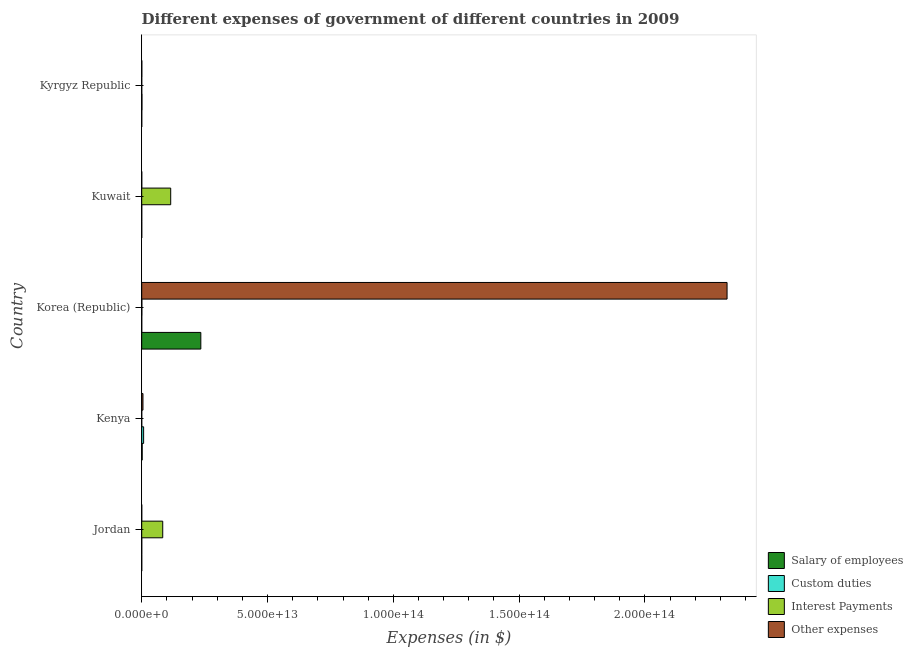Are the number of bars per tick equal to the number of legend labels?
Provide a short and direct response. Yes. Are the number of bars on each tick of the Y-axis equal?
Your response must be concise. Yes. How many bars are there on the 4th tick from the bottom?
Give a very brief answer. 4. What is the label of the 1st group of bars from the top?
Keep it short and to the point. Kyrgyz Republic. What is the amount spent on custom duties in Kuwait?
Your response must be concise. 1.85e+09. Across all countries, what is the maximum amount spent on interest payments?
Ensure brevity in your answer.  1.15e+13. Across all countries, what is the minimum amount spent on salary of employees?
Provide a succinct answer. 2.53e+09. In which country was the amount spent on custom duties maximum?
Offer a terse response. Kenya. In which country was the amount spent on custom duties minimum?
Offer a very short reply. Kuwait. What is the total amount spent on interest payments in the graph?
Offer a very short reply. 1.99e+13. What is the difference between the amount spent on custom duties in Jordan and that in Kyrgyz Republic?
Make the answer very short. -8.48e+1. What is the difference between the amount spent on salary of employees in Kuwait and the amount spent on interest payments in Jordan?
Give a very brief answer. -8.35e+12. What is the average amount spent on salary of employees per country?
Offer a terse response. 4.74e+12. What is the difference between the amount spent on interest payments and amount spent on other expenses in Kenya?
Make the answer very short. -4.93e+11. In how many countries, is the amount spent on interest payments greater than 200000000000000 $?
Make the answer very short. 0. What is the ratio of the amount spent on custom duties in Korea (Republic) to that in Kyrgyz Republic?
Offer a very short reply. 0.02. Is the amount spent on salary of employees in Kenya less than that in Kyrgyz Republic?
Provide a succinct answer. No. Is the difference between the amount spent on custom duties in Jordan and Kyrgyz Republic greater than the difference between the amount spent on salary of employees in Jordan and Kyrgyz Republic?
Offer a terse response. No. What is the difference between the highest and the second highest amount spent on other expenses?
Offer a very short reply. 2.32e+14. What is the difference between the highest and the lowest amount spent on other expenses?
Your answer should be compact. 2.33e+14. What does the 2nd bar from the top in Kyrgyz Republic represents?
Offer a very short reply. Interest Payments. What does the 1st bar from the bottom in Jordan represents?
Offer a terse response. Salary of employees. Is it the case that in every country, the sum of the amount spent on salary of employees and amount spent on custom duties is greater than the amount spent on interest payments?
Your answer should be compact. No. How many bars are there?
Offer a terse response. 20. How many countries are there in the graph?
Your answer should be very brief. 5. What is the difference between two consecutive major ticks on the X-axis?
Offer a very short reply. 5.00e+13. Are the values on the major ticks of X-axis written in scientific E-notation?
Make the answer very short. Yes. Does the graph contain any zero values?
Offer a very short reply. No. Where does the legend appear in the graph?
Offer a terse response. Bottom right. How many legend labels are there?
Offer a terse response. 4. How are the legend labels stacked?
Make the answer very short. Vertical. What is the title of the graph?
Offer a terse response. Different expenses of government of different countries in 2009. What is the label or title of the X-axis?
Your answer should be very brief. Expenses (in $). What is the Expenses (in $) of Salary of employees in Jordan?
Keep it short and to the point. 2.53e+09. What is the Expenses (in $) in Custom duties in Jordan?
Your answer should be very brief. 5.23e+09. What is the Expenses (in $) of Interest Payments in Jordan?
Provide a succinct answer. 8.35e+12. What is the Expenses (in $) in Other expenses in Jordan?
Offer a very short reply. 5.09e+09. What is the Expenses (in $) of Salary of employees in Kenya?
Provide a succinct answer. 1.84e+11. What is the Expenses (in $) in Custom duties in Kenya?
Your answer should be very brief. 7.53e+11. What is the Expenses (in $) of Interest Payments in Kenya?
Make the answer very short. 3.92e+08. What is the Expenses (in $) in Other expenses in Kenya?
Your answer should be very brief. 4.94e+11. What is the Expenses (in $) of Salary of employees in Korea (Republic)?
Your answer should be compact. 2.35e+13. What is the Expenses (in $) in Custom duties in Korea (Republic)?
Your answer should be compact. 2.11e+09. What is the Expenses (in $) of Interest Payments in Korea (Republic)?
Provide a succinct answer. 5.06e+1. What is the Expenses (in $) of Other expenses in Korea (Republic)?
Offer a terse response. 2.33e+14. What is the Expenses (in $) in Salary of employees in Kuwait?
Your answer should be compact. 2.98e+09. What is the Expenses (in $) in Custom duties in Kuwait?
Offer a terse response. 1.85e+09. What is the Expenses (in $) in Interest Payments in Kuwait?
Make the answer very short. 1.15e+13. What is the Expenses (in $) in Other expenses in Kuwait?
Provide a short and direct response. 1.03e+1. What is the Expenses (in $) of Salary of employees in Kyrgyz Republic?
Ensure brevity in your answer.  1.09e+1. What is the Expenses (in $) of Custom duties in Kyrgyz Republic?
Offer a very short reply. 9.01e+1. What is the Expenses (in $) of Interest Payments in Kyrgyz Republic?
Offer a terse response. 1.59e+09. What is the Expenses (in $) in Other expenses in Kyrgyz Republic?
Provide a short and direct response. 3.79e+1. Across all countries, what is the maximum Expenses (in $) in Salary of employees?
Your response must be concise. 2.35e+13. Across all countries, what is the maximum Expenses (in $) of Custom duties?
Give a very brief answer. 7.53e+11. Across all countries, what is the maximum Expenses (in $) of Interest Payments?
Make the answer very short. 1.15e+13. Across all countries, what is the maximum Expenses (in $) of Other expenses?
Offer a very short reply. 2.33e+14. Across all countries, what is the minimum Expenses (in $) of Salary of employees?
Make the answer very short. 2.53e+09. Across all countries, what is the minimum Expenses (in $) of Custom duties?
Make the answer very short. 1.85e+09. Across all countries, what is the minimum Expenses (in $) of Interest Payments?
Provide a short and direct response. 3.92e+08. Across all countries, what is the minimum Expenses (in $) of Other expenses?
Provide a succinct answer. 5.09e+09. What is the total Expenses (in $) in Salary of employees in the graph?
Keep it short and to the point. 2.37e+13. What is the total Expenses (in $) in Custom duties in the graph?
Ensure brevity in your answer.  8.53e+11. What is the total Expenses (in $) in Interest Payments in the graph?
Your response must be concise. 1.99e+13. What is the total Expenses (in $) in Other expenses in the graph?
Offer a terse response. 2.33e+14. What is the difference between the Expenses (in $) of Salary of employees in Jordan and that in Kenya?
Make the answer very short. -1.82e+11. What is the difference between the Expenses (in $) of Custom duties in Jordan and that in Kenya?
Make the answer very short. -7.48e+11. What is the difference between the Expenses (in $) of Interest Payments in Jordan and that in Kenya?
Keep it short and to the point. 8.35e+12. What is the difference between the Expenses (in $) in Other expenses in Jordan and that in Kenya?
Give a very brief answer. -4.89e+11. What is the difference between the Expenses (in $) of Salary of employees in Jordan and that in Korea (Republic)?
Provide a short and direct response. -2.35e+13. What is the difference between the Expenses (in $) in Custom duties in Jordan and that in Korea (Republic)?
Give a very brief answer. 3.11e+09. What is the difference between the Expenses (in $) in Interest Payments in Jordan and that in Korea (Republic)?
Ensure brevity in your answer.  8.30e+12. What is the difference between the Expenses (in $) of Other expenses in Jordan and that in Korea (Republic)?
Provide a succinct answer. -2.33e+14. What is the difference between the Expenses (in $) in Salary of employees in Jordan and that in Kuwait?
Provide a succinct answer. -4.51e+08. What is the difference between the Expenses (in $) in Custom duties in Jordan and that in Kuwait?
Ensure brevity in your answer.  3.38e+09. What is the difference between the Expenses (in $) of Interest Payments in Jordan and that in Kuwait?
Offer a very short reply. -3.17e+12. What is the difference between the Expenses (in $) of Other expenses in Jordan and that in Kuwait?
Your answer should be compact. -5.18e+09. What is the difference between the Expenses (in $) of Salary of employees in Jordan and that in Kyrgyz Republic?
Give a very brief answer. -8.40e+09. What is the difference between the Expenses (in $) of Custom duties in Jordan and that in Kyrgyz Republic?
Offer a very short reply. -8.48e+1. What is the difference between the Expenses (in $) in Interest Payments in Jordan and that in Kyrgyz Republic?
Provide a short and direct response. 8.35e+12. What is the difference between the Expenses (in $) in Other expenses in Jordan and that in Kyrgyz Republic?
Offer a terse response. -3.28e+1. What is the difference between the Expenses (in $) of Salary of employees in Kenya and that in Korea (Republic)?
Provide a succinct answer. -2.33e+13. What is the difference between the Expenses (in $) of Custom duties in Kenya and that in Korea (Republic)?
Ensure brevity in your answer.  7.51e+11. What is the difference between the Expenses (in $) in Interest Payments in Kenya and that in Korea (Republic)?
Keep it short and to the point. -5.02e+1. What is the difference between the Expenses (in $) in Other expenses in Kenya and that in Korea (Republic)?
Provide a short and direct response. -2.32e+14. What is the difference between the Expenses (in $) of Salary of employees in Kenya and that in Kuwait?
Offer a very short reply. 1.81e+11. What is the difference between the Expenses (in $) of Custom duties in Kenya and that in Kuwait?
Your response must be concise. 7.52e+11. What is the difference between the Expenses (in $) of Interest Payments in Kenya and that in Kuwait?
Your answer should be very brief. -1.15e+13. What is the difference between the Expenses (in $) in Other expenses in Kenya and that in Kuwait?
Offer a terse response. 4.84e+11. What is the difference between the Expenses (in $) in Salary of employees in Kenya and that in Kyrgyz Republic?
Make the answer very short. 1.73e+11. What is the difference between the Expenses (in $) in Custom duties in Kenya and that in Kyrgyz Republic?
Make the answer very short. 6.63e+11. What is the difference between the Expenses (in $) in Interest Payments in Kenya and that in Kyrgyz Republic?
Keep it short and to the point. -1.20e+09. What is the difference between the Expenses (in $) of Other expenses in Kenya and that in Kyrgyz Republic?
Provide a short and direct response. 4.56e+11. What is the difference between the Expenses (in $) in Salary of employees in Korea (Republic) and that in Kuwait?
Your response must be concise. 2.35e+13. What is the difference between the Expenses (in $) of Custom duties in Korea (Republic) and that in Kuwait?
Make the answer very short. 2.65e+08. What is the difference between the Expenses (in $) in Interest Payments in Korea (Republic) and that in Kuwait?
Give a very brief answer. -1.15e+13. What is the difference between the Expenses (in $) of Other expenses in Korea (Republic) and that in Kuwait?
Ensure brevity in your answer.  2.33e+14. What is the difference between the Expenses (in $) in Salary of employees in Korea (Republic) and that in Kyrgyz Republic?
Provide a succinct answer. 2.35e+13. What is the difference between the Expenses (in $) of Custom duties in Korea (Republic) and that in Kyrgyz Republic?
Your answer should be compact. -8.79e+1. What is the difference between the Expenses (in $) in Interest Payments in Korea (Republic) and that in Kyrgyz Republic?
Your response must be concise. 4.90e+1. What is the difference between the Expenses (in $) in Other expenses in Korea (Republic) and that in Kyrgyz Republic?
Offer a very short reply. 2.33e+14. What is the difference between the Expenses (in $) in Salary of employees in Kuwait and that in Kyrgyz Republic?
Offer a very short reply. -7.95e+09. What is the difference between the Expenses (in $) of Custom duties in Kuwait and that in Kyrgyz Republic?
Your answer should be compact. -8.82e+1. What is the difference between the Expenses (in $) of Interest Payments in Kuwait and that in Kyrgyz Republic?
Offer a very short reply. 1.15e+13. What is the difference between the Expenses (in $) in Other expenses in Kuwait and that in Kyrgyz Republic?
Provide a short and direct response. -2.76e+1. What is the difference between the Expenses (in $) of Salary of employees in Jordan and the Expenses (in $) of Custom duties in Kenya?
Give a very brief answer. -7.51e+11. What is the difference between the Expenses (in $) in Salary of employees in Jordan and the Expenses (in $) in Interest Payments in Kenya?
Keep it short and to the point. 2.14e+09. What is the difference between the Expenses (in $) of Salary of employees in Jordan and the Expenses (in $) of Other expenses in Kenya?
Give a very brief answer. -4.91e+11. What is the difference between the Expenses (in $) of Custom duties in Jordan and the Expenses (in $) of Interest Payments in Kenya?
Make the answer very short. 4.84e+09. What is the difference between the Expenses (in $) of Custom duties in Jordan and the Expenses (in $) of Other expenses in Kenya?
Provide a short and direct response. -4.89e+11. What is the difference between the Expenses (in $) in Interest Payments in Jordan and the Expenses (in $) in Other expenses in Kenya?
Ensure brevity in your answer.  7.86e+12. What is the difference between the Expenses (in $) of Salary of employees in Jordan and the Expenses (in $) of Custom duties in Korea (Republic)?
Your answer should be very brief. 4.19e+08. What is the difference between the Expenses (in $) of Salary of employees in Jordan and the Expenses (in $) of Interest Payments in Korea (Republic)?
Give a very brief answer. -4.81e+1. What is the difference between the Expenses (in $) in Salary of employees in Jordan and the Expenses (in $) in Other expenses in Korea (Republic)?
Your answer should be very brief. -2.33e+14. What is the difference between the Expenses (in $) of Custom duties in Jordan and the Expenses (in $) of Interest Payments in Korea (Republic)?
Your answer should be very brief. -4.54e+1. What is the difference between the Expenses (in $) in Custom duties in Jordan and the Expenses (in $) in Other expenses in Korea (Republic)?
Make the answer very short. -2.33e+14. What is the difference between the Expenses (in $) of Interest Payments in Jordan and the Expenses (in $) of Other expenses in Korea (Republic)?
Your answer should be compact. -2.24e+14. What is the difference between the Expenses (in $) of Salary of employees in Jordan and the Expenses (in $) of Custom duties in Kuwait?
Your response must be concise. 6.84e+08. What is the difference between the Expenses (in $) in Salary of employees in Jordan and the Expenses (in $) in Interest Payments in Kuwait?
Your answer should be very brief. -1.15e+13. What is the difference between the Expenses (in $) in Salary of employees in Jordan and the Expenses (in $) in Other expenses in Kuwait?
Keep it short and to the point. -7.74e+09. What is the difference between the Expenses (in $) of Custom duties in Jordan and the Expenses (in $) of Interest Payments in Kuwait?
Provide a succinct answer. -1.15e+13. What is the difference between the Expenses (in $) in Custom duties in Jordan and the Expenses (in $) in Other expenses in Kuwait?
Provide a succinct answer. -5.04e+09. What is the difference between the Expenses (in $) in Interest Payments in Jordan and the Expenses (in $) in Other expenses in Kuwait?
Offer a terse response. 8.34e+12. What is the difference between the Expenses (in $) of Salary of employees in Jordan and the Expenses (in $) of Custom duties in Kyrgyz Republic?
Offer a very short reply. -8.75e+1. What is the difference between the Expenses (in $) of Salary of employees in Jordan and the Expenses (in $) of Interest Payments in Kyrgyz Republic?
Make the answer very short. 9.41e+08. What is the difference between the Expenses (in $) of Salary of employees in Jordan and the Expenses (in $) of Other expenses in Kyrgyz Republic?
Provide a short and direct response. -3.53e+1. What is the difference between the Expenses (in $) of Custom duties in Jordan and the Expenses (in $) of Interest Payments in Kyrgyz Republic?
Your answer should be compact. 3.64e+09. What is the difference between the Expenses (in $) of Custom duties in Jordan and the Expenses (in $) of Other expenses in Kyrgyz Republic?
Give a very brief answer. -3.26e+1. What is the difference between the Expenses (in $) of Interest Payments in Jordan and the Expenses (in $) of Other expenses in Kyrgyz Republic?
Your answer should be very brief. 8.31e+12. What is the difference between the Expenses (in $) of Salary of employees in Kenya and the Expenses (in $) of Custom duties in Korea (Republic)?
Your response must be concise. 1.82e+11. What is the difference between the Expenses (in $) of Salary of employees in Kenya and the Expenses (in $) of Interest Payments in Korea (Republic)?
Give a very brief answer. 1.34e+11. What is the difference between the Expenses (in $) in Salary of employees in Kenya and the Expenses (in $) in Other expenses in Korea (Republic)?
Offer a very short reply. -2.32e+14. What is the difference between the Expenses (in $) of Custom duties in Kenya and the Expenses (in $) of Interest Payments in Korea (Republic)?
Your answer should be very brief. 7.03e+11. What is the difference between the Expenses (in $) in Custom duties in Kenya and the Expenses (in $) in Other expenses in Korea (Republic)?
Keep it short and to the point. -2.32e+14. What is the difference between the Expenses (in $) in Interest Payments in Kenya and the Expenses (in $) in Other expenses in Korea (Republic)?
Your response must be concise. -2.33e+14. What is the difference between the Expenses (in $) in Salary of employees in Kenya and the Expenses (in $) in Custom duties in Kuwait?
Your answer should be very brief. 1.82e+11. What is the difference between the Expenses (in $) of Salary of employees in Kenya and the Expenses (in $) of Interest Payments in Kuwait?
Give a very brief answer. -1.13e+13. What is the difference between the Expenses (in $) in Salary of employees in Kenya and the Expenses (in $) in Other expenses in Kuwait?
Your response must be concise. 1.74e+11. What is the difference between the Expenses (in $) in Custom duties in Kenya and the Expenses (in $) in Interest Payments in Kuwait?
Ensure brevity in your answer.  -1.08e+13. What is the difference between the Expenses (in $) in Custom duties in Kenya and the Expenses (in $) in Other expenses in Kuwait?
Give a very brief answer. 7.43e+11. What is the difference between the Expenses (in $) in Interest Payments in Kenya and the Expenses (in $) in Other expenses in Kuwait?
Your answer should be very brief. -9.88e+09. What is the difference between the Expenses (in $) in Salary of employees in Kenya and the Expenses (in $) in Custom duties in Kyrgyz Republic?
Your answer should be very brief. 9.42e+1. What is the difference between the Expenses (in $) in Salary of employees in Kenya and the Expenses (in $) in Interest Payments in Kyrgyz Republic?
Your answer should be compact. 1.83e+11. What is the difference between the Expenses (in $) in Salary of employees in Kenya and the Expenses (in $) in Other expenses in Kyrgyz Republic?
Make the answer very short. 1.46e+11. What is the difference between the Expenses (in $) in Custom duties in Kenya and the Expenses (in $) in Interest Payments in Kyrgyz Republic?
Your answer should be very brief. 7.52e+11. What is the difference between the Expenses (in $) in Custom duties in Kenya and the Expenses (in $) in Other expenses in Kyrgyz Republic?
Offer a very short reply. 7.16e+11. What is the difference between the Expenses (in $) of Interest Payments in Kenya and the Expenses (in $) of Other expenses in Kyrgyz Republic?
Offer a terse response. -3.75e+1. What is the difference between the Expenses (in $) in Salary of employees in Korea (Republic) and the Expenses (in $) in Custom duties in Kuwait?
Keep it short and to the point. 2.35e+13. What is the difference between the Expenses (in $) of Salary of employees in Korea (Republic) and the Expenses (in $) of Interest Payments in Kuwait?
Offer a very short reply. 1.20e+13. What is the difference between the Expenses (in $) in Salary of employees in Korea (Republic) and the Expenses (in $) in Other expenses in Kuwait?
Offer a terse response. 2.35e+13. What is the difference between the Expenses (in $) in Custom duties in Korea (Republic) and the Expenses (in $) in Interest Payments in Kuwait?
Provide a succinct answer. -1.15e+13. What is the difference between the Expenses (in $) in Custom duties in Korea (Republic) and the Expenses (in $) in Other expenses in Kuwait?
Keep it short and to the point. -8.15e+09. What is the difference between the Expenses (in $) of Interest Payments in Korea (Republic) and the Expenses (in $) of Other expenses in Kuwait?
Your answer should be very brief. 4.04e+1. What is the difference between the Expenses (in $) of Salary of employees in Korea (Republic) and the Expenses (in $) of Custom duties in Kyrgyz Republic?
Make the answer very short. 2.34e+13. What is the difference between the Expenses (in $) in Salary of employees in Korea (Republic) and the Expenses (in $) in Interest Payments in Kyrgyz Republic?
Give a very brief answer. 2.35e+13. What is the difference between the Expenses (in $) in Salary of employees in Korea (Republic) and the Expenses (in $) in Other expenses in Kyrgyz Republic?
Your response must be concise. 2.35e+13. What is the difference between the Expenses (in $) of Custom duties in Korea (Republic) and the Expenses (in $) of Interest Payments in Kyrgyz Republic?
Offer a terse response. 5.22e+08. What is the difference between the Expenses (in $) of Custom duties in Korea (Republic) and the Expenses (in $) of Other expenses in Kyrgyz Republic?
Make the answer very short. -3.57e+1. What is the difference between the Expenses (in $) in Interest Payments in Korea (Republic) and the Expenses (in $) in Other expenses in Kyrgyz Republic?
Make the answer very short. 1.28e+1. What is the difference between the Expenses (in $) of Salary of employees in Kuwait and the Expenses (in $) of Custom duties in Kyrgyz Republic?
Give a very brief answer. -8.71e+1. What is the difference between the Expenses (in $) in Salary of employees in Kuwait and the Expenses (in $) in Interest Payments in Kyrgyz Republic?
Your response must be concise. 1.39e+09. What is the difference between the Expenses (in $) in Salary of employees in Kuwait and the Expenses (in $) in Other expenses in Kyrgyz Republic?
Give a very brief answer. -3.49e+1. What is the difference between the Expenses (in $) in Custom duties in Kuwait and the Expenses (in $) in Interest Payments in Kyrgyz Republic?
Keep it short and to the point. 2.56e+08. What is the difference between the Expenses (in $) of Custom duties in Kuwait and the Expenses (in $) of Other expenses in Kyrgyz Republic?
Ensure brevity in your answer.  -3.60e+1. What is the difference between the Expenses (in $) of Interest Payments in Kuwait and the Expenses (in $) of Other expenses in Kyrgyz Republic?
Make the answer very short. 1.15e+13. What is the average Expenses (in $) of Salary of employees per country?
Offer a terse response. 4.74e+12. What is the average Expenses (in $) of Custom duties per country?
Keep it short and to the point. 1.71e+11. What is the average Expenses (in $) in Interest Payments per country?
Provide a short and direct response. 3.98e+12. What is the average Expenses (in $) of Other expenses per country?
Provide a succinct answer. 4.66e+13. What is the difference between the Expenses (in $) in Salary of employees and Expenses (in $) in Custom duties in Jordan?
Provide a short and direct response. -2.70e+09. What is the difference between the Expenses (in $) of Salary of employees and Expenses (in $) of Interest Payments in Jordan?
Offer a very short reply. -8.35e+12. What is the difference between the Expenses (in $) in Salary of employees and Expenses (in $) in Other expenses in Jordan?
Ensure brevity in your answer.  -2.56e+09. What is the difference between the Expenses (in $) in Custom duties and Expenses (in $) in Interest Payments in Jordan?
Your answer should be very brief. -8.35e+12. What is the difference between the Expenses (in $) in Custom duties and Expenses (in $) in Other expenses in Jordan?
Offer a terse response. 1.39e+08. What is the difference between the Expenses (in $) in Interest Payments and Expenses (in $) in Other expenses in Jordan?
Provide a short and direct response. 8.35e+12. What is the difference between the Expenses (in $) in Salary of employees and Expenses (in $) in Custom duties in Kenya?
Provide a succinct answer. -5.69e+11. What is the difference between the Expenses (in $) of Salary of employees and Expenses (in $) of Interest Payments in Kenya?
Provide a short and direct response. 1.84e+11. What is the difference between the Expenses (in $) of Salary of employees and Expenses (in $) of Other expenses in Kenya?
Offer a very short reply. -3.10e+11. What is the difference between the Expenses (in $) of Custom duties and Expenses (in $) of Interest Payments in Kenya?
Make the answer very short. 7.53e+11. What is the difference between the Expenses (in $) of Custom duties and Expenses (in $) of Other expenses in Kenya?
Your answer should be very brief. 2.60e+11. What is the difference between the Expenses (in $) of Interest Payments and Expenses (in $) of Other expenses in Kenya?
Your response must be concise. -4.93e+11. What is the difference between the Expenses (in $) of Salary of employees and Expenses (in $) of Custom duties in Korea (Republic)?
Your answer should be very brief. 2.35e+13. What is the difference between the Expenses (in $) in Salary of employees and Expenses (in $) in Interest Payments in Korea (Republic)?
Provide a succinct answer. 2.34e+13. What is the difference between the Expenses (in $) of Salary of employees and Expenses (in $) of Other expenses in Korea (Republic)?
Make the answer very short. -2.09e+14. What is the difference between the Expenses (in $) of Custom duties and Expenses (in $) of Interest Payments in Korea (Republic)?
Provide a succinct answer. -4.85e+1. What is the difference between the Expenses (in $) in Custom duties and Expenses (in $) in Other expenses in Korea (Republic)?
Give a very brief answer. -2.33e+14. What is the difference between the Expenses (in $) in Interest Payments and Expenses (in $) in Other expenses in Korea (Republic)?
Offer a terse response. -2.33e+14. What is the difference between the Expenses (in $) of Salary of employees and Expenses (in $) of Custom duties in Kuwait?
Make the answer very short. 1.14e+09. What is the difference between the Expenses (in $) of Salary of employees and Expenses (in $) of Interest Payments in Kuwait?
Make the answer very short. -1.15e+13. What is the difference between the Expenses (in $) in Salary of employees and Expenses (in $) in Other expenses in Kuwait?
Your response must be concise. -7.28e+09. What is the difference between the Expenses (in $) in Custom duties and Expenses (in $) in Interest Payments in Kuwait?
Give a very brief answer. -1.15e+13. What is the difference between the Expenses (in $) in Custom duties and Expenses (in $) in Other expenses in Kuwait?
Offer a terse response. -8.42e+09. What is the difference between the Expenses (in $) of Interest Payments and Expenses (in $) of Other expenses in Kuwait?
Your answer should be very brief. 1.15e+13. What is the difference between the Expenses (in $) of Salary of employees and Expenses (in $) of Custom duties in Kyrgyz Republic?
Provide a succinct answer. -7.91e+1. What is the difference between the Expenses (in $) of Salary of employees and Expenses (in $) of Interest Payments in Kyrgyz Republic?
Your response must be concise. 9.34e+09. What is the difference between the Expenses (in $) in Salary of employees and Expenses (in $) in Other expenses in Kyrgyz Republic?
Offer a terse response. -2.69e+1. What is the difference between the Expenses (in $) in Custom duties and Expenses (in $) in Interest Payments in Kyrgyz Republic?
Your answer should be very brief. 8.85e+1. What is the difference between the Expenses (in $) of Custom duties and Expenses (in $) of Other expenses in Kyrgyz Republic?
Ensure brevity in your answer.  5.22e+1. What is the difference between the Expenses (in $) of Interest Payments and Expenses (in $) of Other expenses in Kyrgyz Republic?
Your answer should be very brief. -3.63e+1. What is the ratio of the Expenses (in $) in Salary of employees in Jordan to that in Kenya?
Ensure brevity in your answer.  0.01. What is the ratio of the Expenses (in $) of Custom duties in Jordan to that in Kenya?
Give a very brief answer. 0.01. What is the ratio of the Expenses (in $) of Interest Payments in Jordan to that in Kenya?
Keep it short and to the point. 2.13e+04. What is the ratio of the Expenses (in $) in Other expenses in Jordan to that in Kenya?
Your response must be concise. 0.01. What is the ratio of the Expenses (in $) in Salary of employees in Jordan to that in Korea (Republic)?
Offer a very short reply. 0. What is the ratio of the Expenses (in $) in Custom duties in Jordan to that in Korea (Republic)?
Provide a succinct answer. 2.47. What is the ratio of the Expenses (in $) in Interest Payments in Jordan to that in Korea (Republic)?
Your response must be concise. 164.94. What is the ratio of the Expenses (in $) of Salary of employees in Jordan to that in Kuwait?
Keep it short and to the point. 0.85. What is the ratio of the Expenses (in $) of Custom duties in Jordan to that in Kuwait?
Provide a short and direct response. 2.83. What is the ratio of the Expenses (in $) of Interest Payments in Jordan to that in Kuwait?
Your response must be concise. 0.73. What is the ratio of the Expenses (in $) of Other expenses in Jordan to that in Kuwait?
Offer a terse response. 0.5. What is the ratio of the Expenses (in $) in Salary of employees in Jordan to that in Kyrgyz Republic?
Your answer should be compact. 0.23. What is the ratio of the Expenses (in $) in Custom duties in Jordan to that in Kyrgyz Republic?
Offer a very short reply. 0.06. What is the ratio of the Expenses (in $) of Interest Payments in Jordan to that in Kyrgyz Republic?
Provide a short and direct response. 5244.97. What is the ratio of the Expenses (in $) of Other expenses in Jordan to that in Kyrgyz Republic?
Provide a succinct answer. 0.13. What is the ratio of the Expenses (in $) in Salary of employees in Kenya to that in Korea (Republic)?
Offer a terse response. 0.01. What is the ratio of the Expenses (in $) of Custom duties in Kenya to that in Korea (Republic)?
Make the answer very short. 356.36. What is the ratio of the Expenses (in $) in Interest Payments in Kenya to that in Korea (Republic)?
Your response must be concise. 0.01. What is the ratio of the Expenses (in $) in Other expenses in Kenya to that in Korea (Republic)?
Your response must be concise. 0. What is the ratio of the Expenses (in $) in Salary of employees in Kenya to that in Kuwait?
Make the answer very short. 61.74. What is the ratio of the Expenses (in $) of Custom duties in Kenya to that in Kuwait?
Your response must be concise. 407.52. What is the ratio of the Expenses (in $) in Interest Payments in Kenya to that in Kuwait?
Offer a terse response. 0. What is the ratio of the Expenses (in $) in Other expenses in Kenya to that in Kuwait?
Offer a very short reply. 48.08. What is the ratio of the Expenses (in $) in Salary of employees in Kenya to that in Kyrgyz Republic?
Make the answer very short. 16.85. What is the ratio of the Expenses (in $) of Custom duties in Kenya to that in Kyrgyz Republic?
Provide a succinct answer. 8.37. What is the ratio of the Expenses (in $) of Interest Payments in Kenya to that in Kyrgyz Republic?
Make the answer very short. 0.25. What is the ratio of the Expenses (in $) of Other expenses in Kenya to that in Kyrgyz Republic?
Your answer should be very brief. 13.04. What is the ratio of the Expenses (in $) in Salary of employees in Korea (Republic) to that in Kuwait?
Your answer should be very brief. 7872.23. What is the ratio of the Expenses (in $) of Custom duties in Korea (Republic) to that in Kuwait?
Your answer should be compact. 1.14. What is the ratio of the Expenses (in $) of Interest Payments in Korea (Republic) to that in Kuwait?
Provide a succinct answer. 0. What is the ratio of the Expenses (in $) of Other expenses in Korea (Republic) to that in Kuwait?
Make the answer very short. 2.27e+04. What is the ratio of the Expenses (in $) in Salary of employees in Korea (Republic) to that in Kyrgyz Republic?
Give a very brief answer. 2148.98. What is the ratio of the Expenses (in $) in Custom duties in Korea (Republic) to that in Kyrgyz Republic?
Ensure brevity in your answer.  0.02. What is the ratio of the Expenses (in $) in Interest Payments in Korea (Republic) to that in Kyrgyz Republic?
Keep it short and to the point. 31.8. What is the ratio of the Expenses (in $) of Other expenses in Korea (Republic) to that in Kyrgyz Republic?
Ensure brevity in your answer.  6146.24. What is the ratio of the Expenses (in $) in Salary of employees in Kuwait to that in Kyrgyz Republic?
Provide a succinct answer. 0.27. What is the ratio of the Expenses (in $) of Custom duties in Kuwait to that in Kyrgyz Republic?
Offer a very short reply. 0.02. What is the ratio of the Expenses (in $) in Interest Payments in Kuwait to that in Kyrgyz Republic?
Offer a terse response. 7233.47. What is the ratio of the Expenses (in $) of Other expenses in Kuwait to that in Kyrgyz Republic?
Your answer should be compact. 0.27. What is the difference between the highest and the second highest Expenses (in $) of Salary of employees?
Your answer should be compact. 2.33e+13. What is the difference between the highest and the second highest Expenses (in $) of Custom duties?
Ensure brevity in your answer.  6.63e+11. What is the difference between the highest and the second highest Expenses (in $) in Interest Payments?
Your answer should be compact. 3.17e+12. What is the difference between the highest and the second highest Expenses (in $) in Other expenses?
Give a very brief answer. 2.32e+14. What is the difference between the highest and the lowest Expenses (in $) of Salary of employees?
Your answer should be very brief. 2.35e+13. What is the difference between the highest and the lowest Expenses (in $) in Custom duties?
Provide a short and direct response. 7.52e+11. What is the difference between the highest and the lowest Expenses (in $) in Interest Payments?
Provide a succinct answer. 1.15e+13. What is the difference between the highest and the lowest Expenses (in $) of Other expenses?
Offer a terse response. 2.33e+14. 